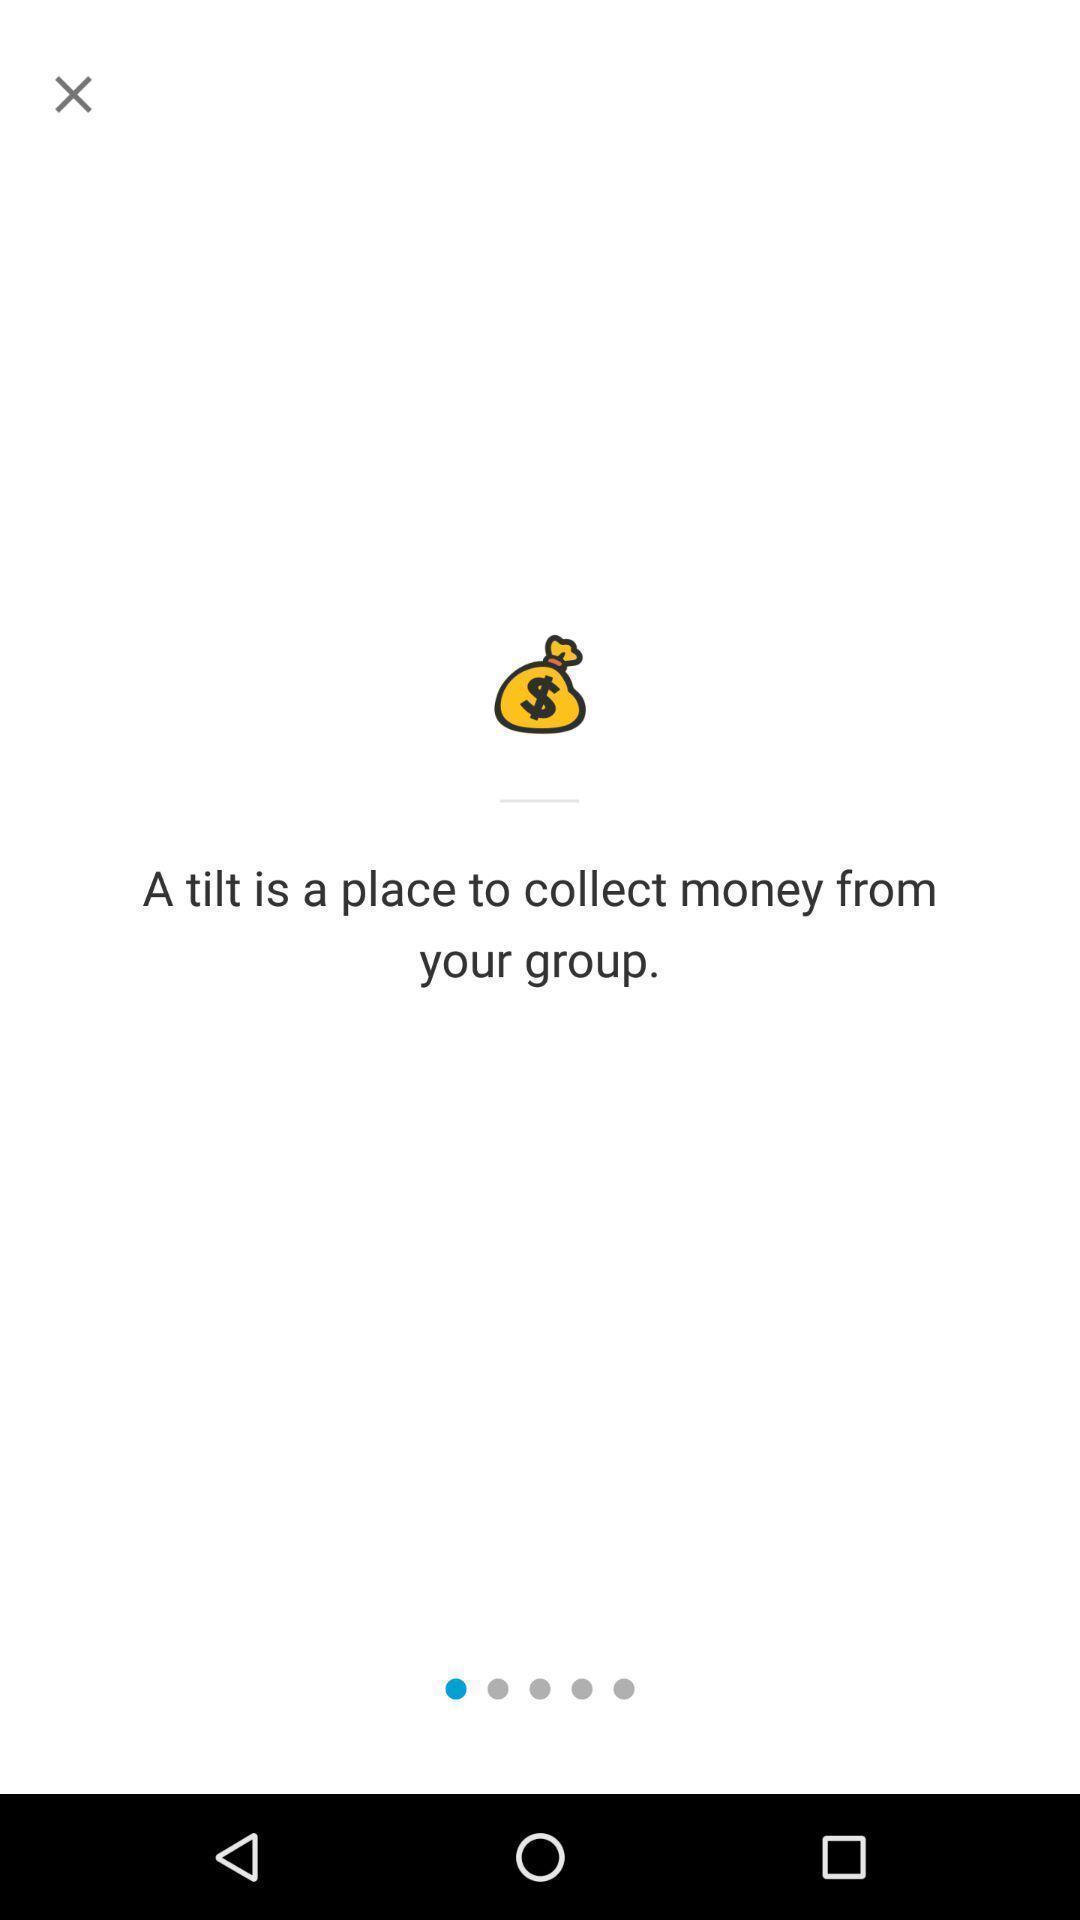Describe the content in this image. Welcome page of a financial app. 